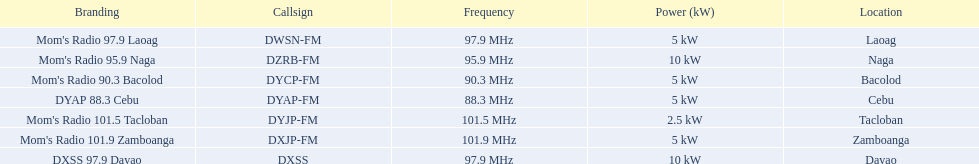Which brands possess a 5 kw capacity? Mom's Radio 97.9 Laoag, Mom's Radio 90.3 Bacolod, DYAP 88.3 Cebu, Mom's Radio 101.9 Zamboanga. Among them, which has a call-sign starting with dy? Mom's Radio 90.3 Bacolod, DYAP 88.3 Cebu. From those, which operates at the lowest frequency? DYAP 88.3 Cebu. 